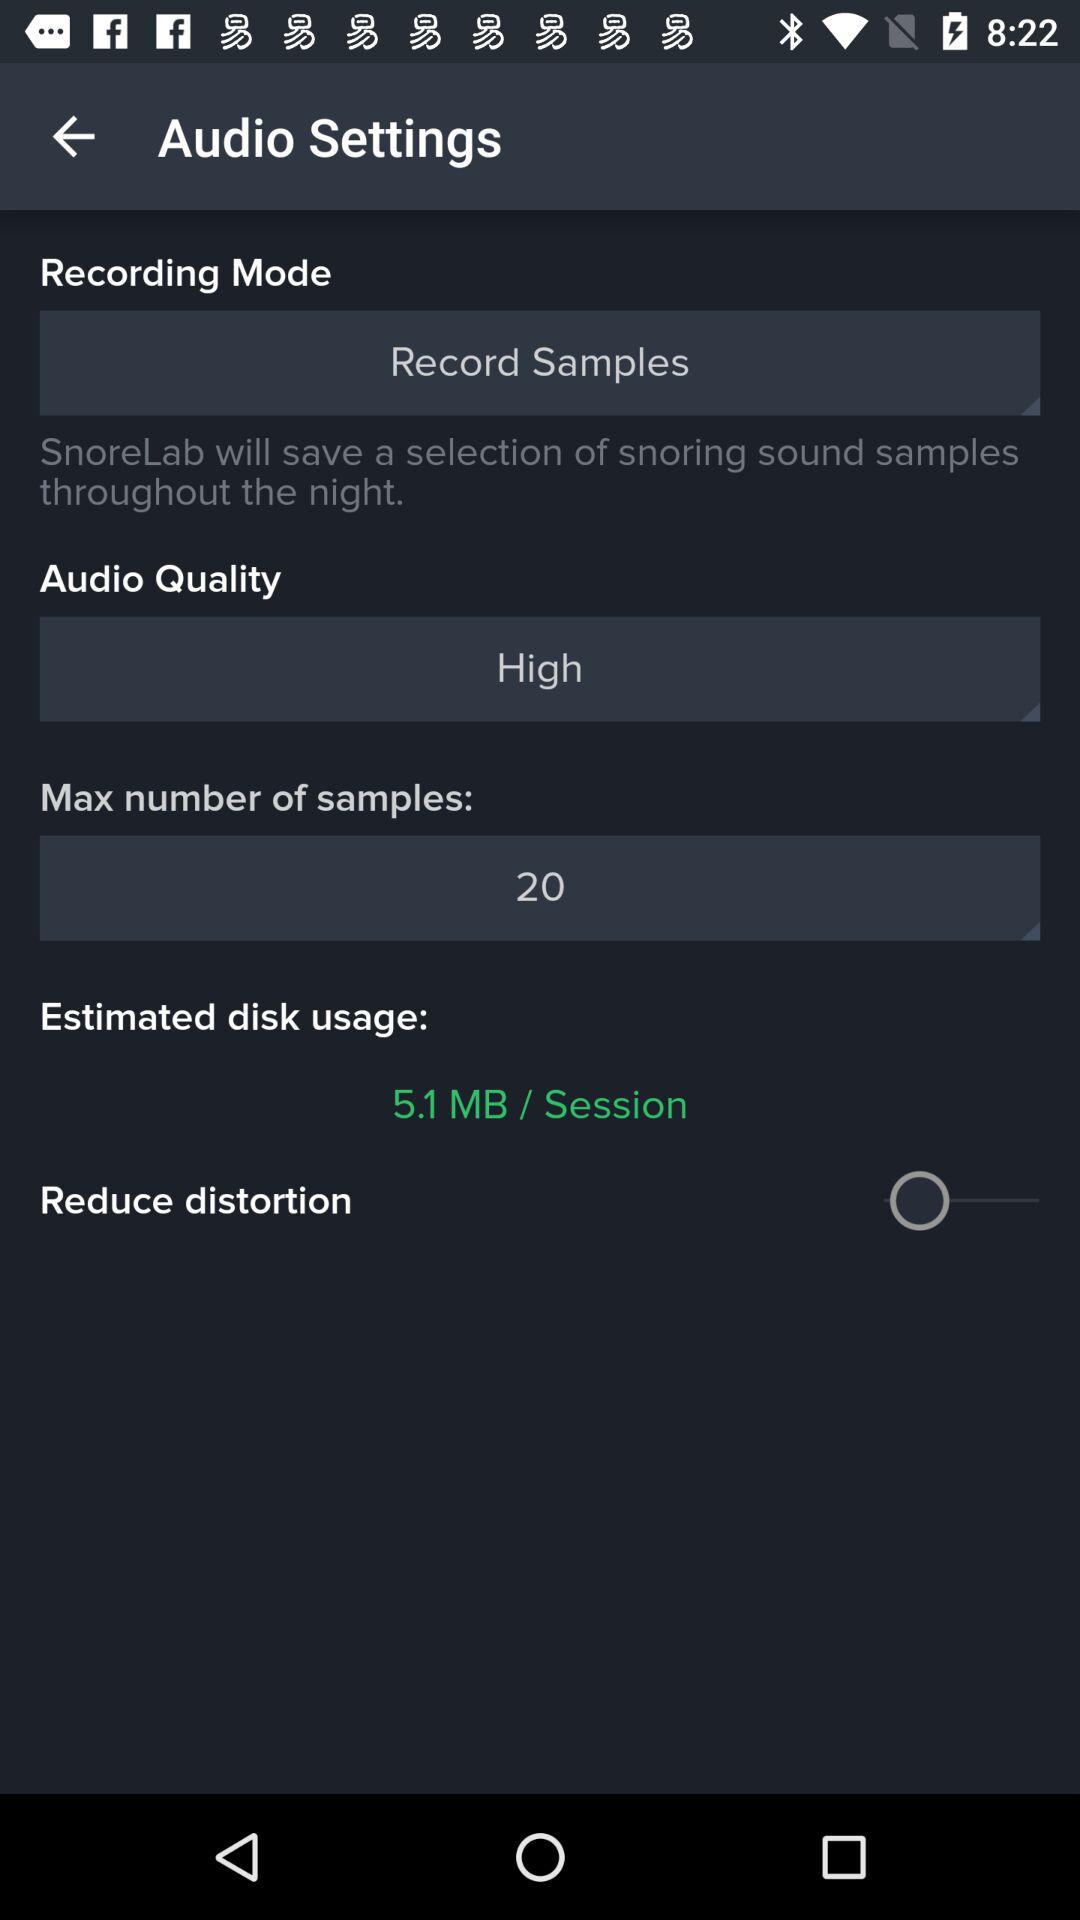What is the selected mode of recording? The selected mode of recording is "Record Samples". 